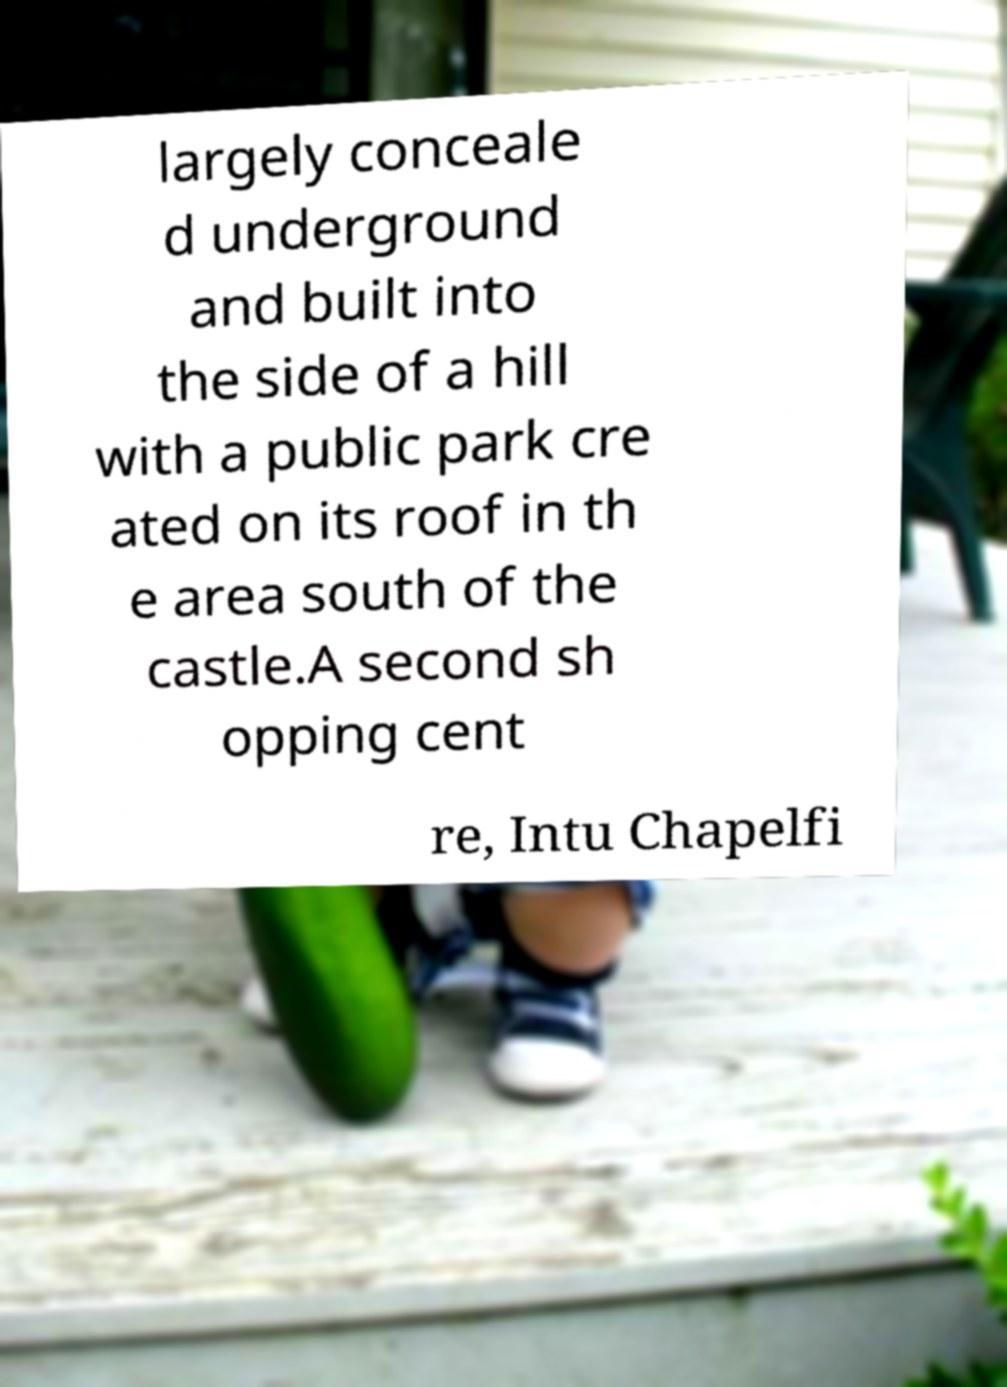Could you extract and type out the text from this image? largely conceale d underground and built into the side of a hill with a public park cre ated on its roof in th e area south of the castle.A second sh opping cent re, Intu Chapelfi 